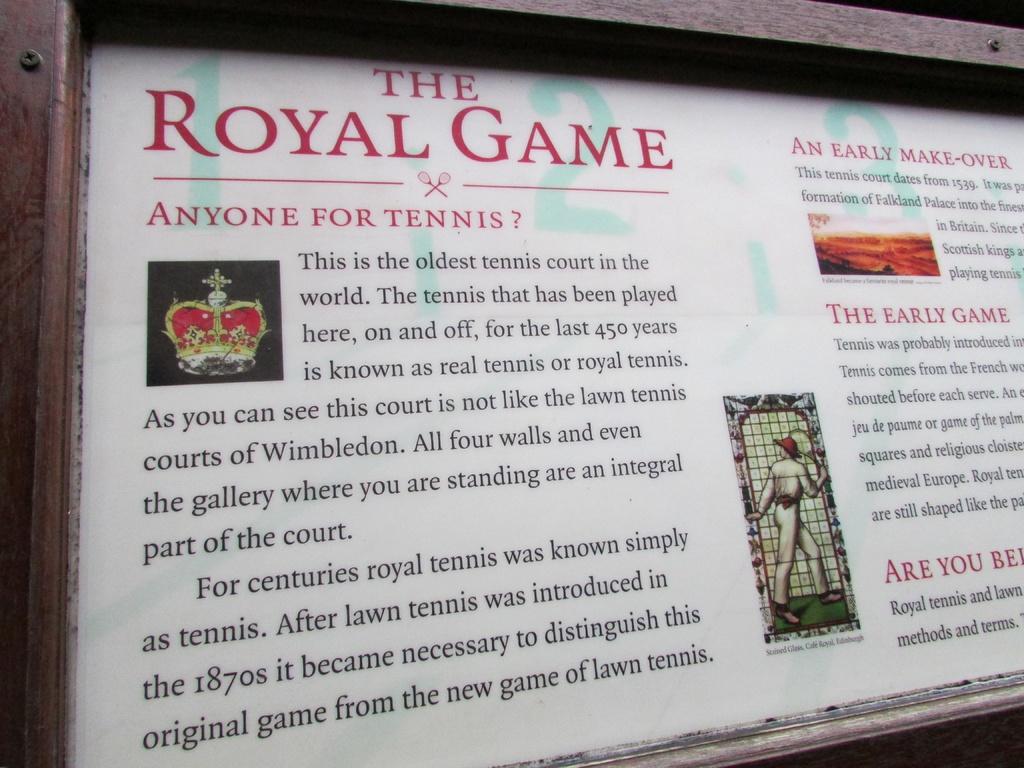What is the title of the page?
Offer a terse response. The royal game. 